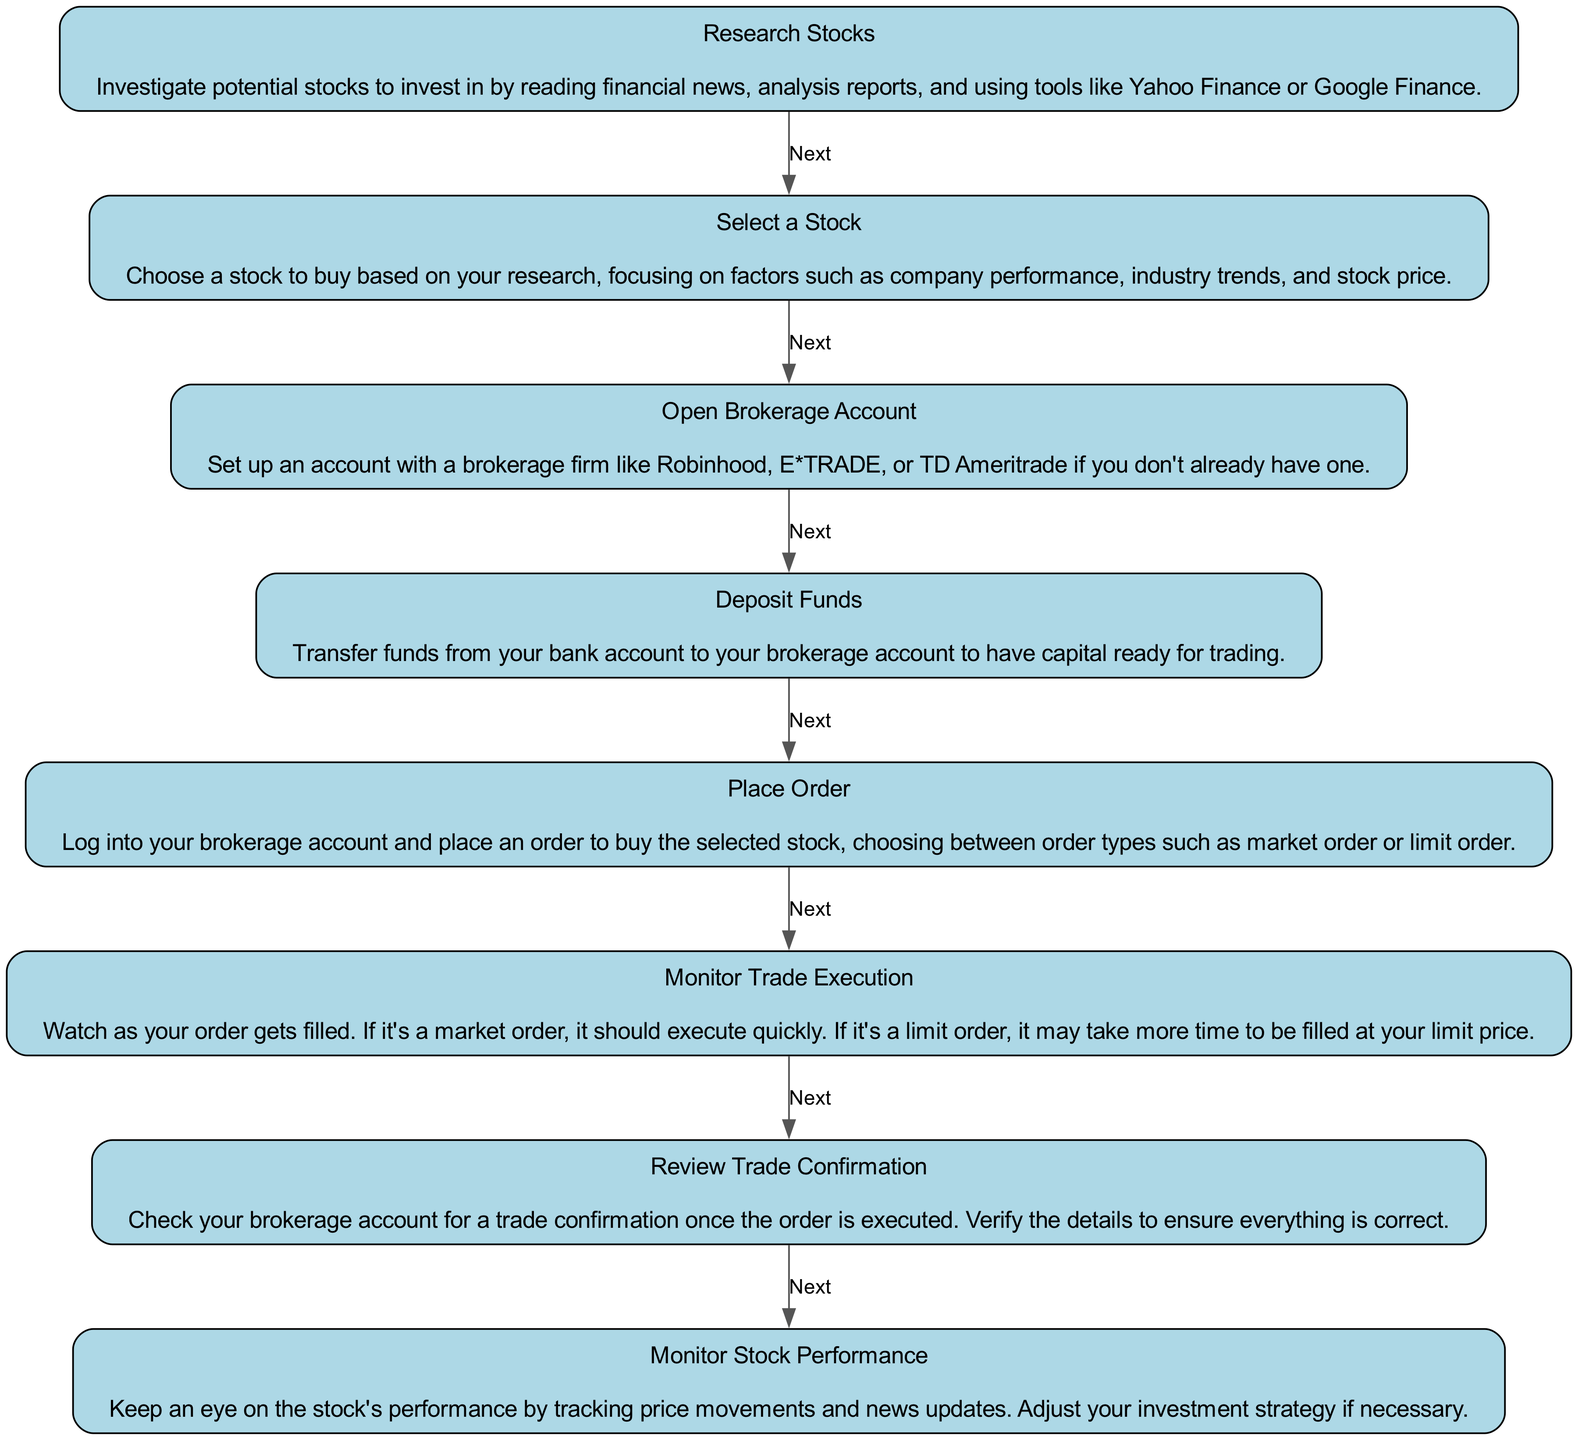What is the first step in the stock trading workflow? The first step in the workflow is to "Research Stocks." This can be found as the first element in the diagram, which depicts the initial phase of the stock trading process.
Answer: Research Stocks How many nodes are in the diagram? By counting the distinct elements presented in the data, there are a total of eight nodes in the diagram representing different steps in the stock trading workflow.
Answer: Eight What is the last step in the workflow? The last step in the workflow is "Monitor Stock Performance," as indicated by the last element in the series of steps that leads to no additional steps.
Answer: Monitor Stock Performance Which step comes immediately after "Select a Stock"? After "Select a Stock," the next step is "Open Brokerage Account." This follows directly in the sequence as outlined in the chart.
Answer: Open Brokerage Account What is the purpose of the "Monitor Trade Execution" step? The purpose of the "Monitor Trade Execution" step is to observe the execution status of the order placed for the stock, whether it is filled immediately or takes time based on the order type.
Answer: To observe order execution If you want to buy a stock, what must you do after depositing funds? After depositing funds, the next action is to "Place Order" for the stock you wish to buy, according to the workflow represented in the diagram.
Answer: Place Order What type of order should you be aware of during the "Place Order" step? During the "Place Order" step, you should be aware of different order types, specifically "market order" or "limit order," as these influence how your trade is executed.
Answer: Market order or limit order How do you verify the execution of a trade? You verify the execution of a trade by reviewing the "Trade Confirmation" in your brokerage account once the order has been executed, ensuring all details are accurate.
Answer: Review Trade Confirmation 